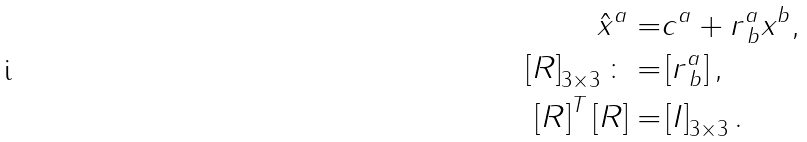Convert formula to latex. <formula><loc_0><loc_0><loc_500><loc_500>\hat { x } ^ { a } = & c ^ { a } + r ^ { a } _ { \, b } x ^ { b } , \\ \left [ R \right ] _ { 3 \times 3 } \colon = & \left [ r ^ { a } _ { \, b } \right ] , \\ \left [ R \right ] ^ { T } \left [ R \right ] = & \left [ I \right ] _ { 3 \times 3 } .</formula> 